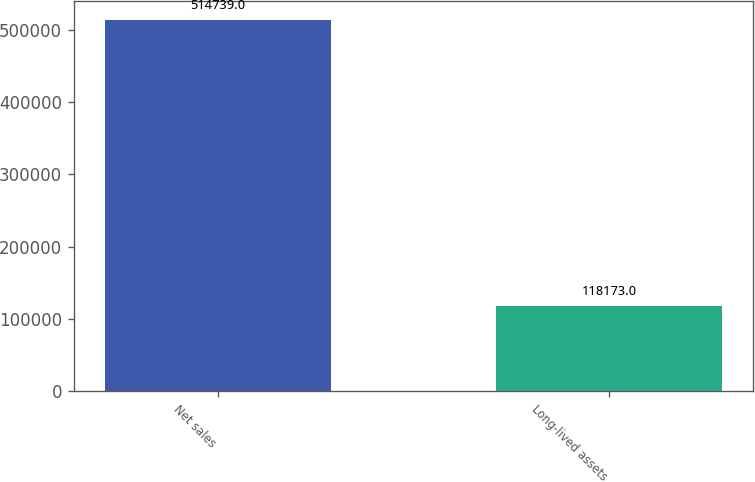<chart> <loc_0><loc_0><loc_500><loc_500><bar_chart><fcel>Net sales<fcel>Long-lived assets<nl><fcel>514739<fcel>118173<nl></chart> 